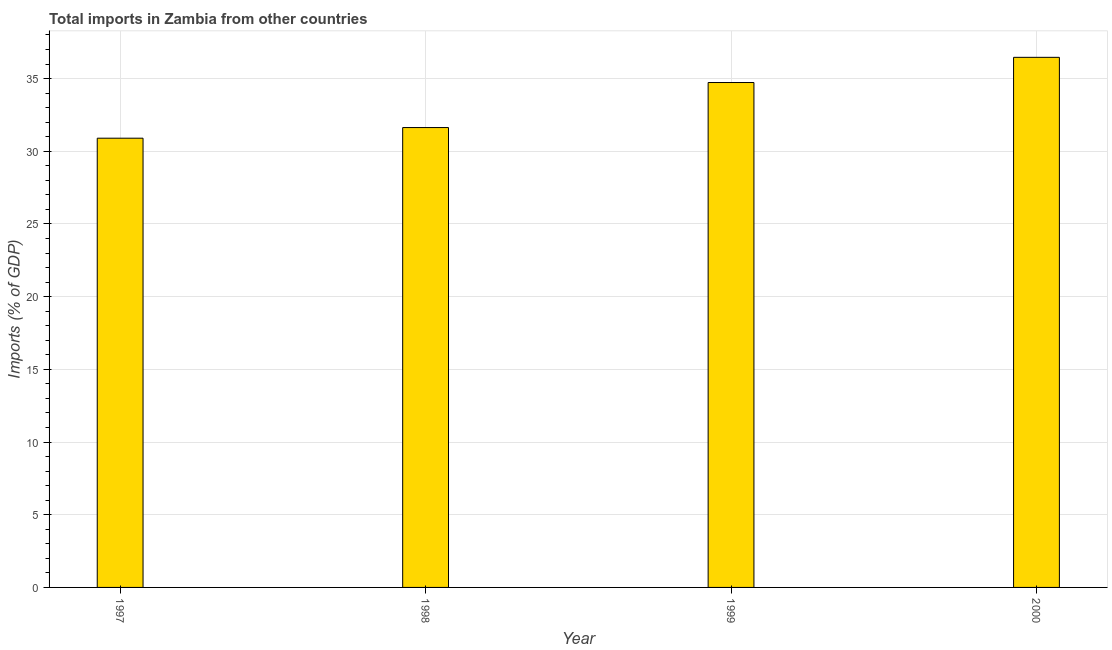What is the title of the graph?
Keep it short and to the point. Total imports in Zambia from other countries. What is the label or title of the Y-axis?
Offer a very short reply. Imports (% of GDP). What is the total imports in 1997?
Keep it short and to the point. 30.9. Across all years, what is the maximum total imports?
Ensure brevity in your answer.  36.46. Across all years, what is the minimum total imports?
Keep it short and to the point. 30.9. In which year was the total imports maximum?
Your answer should be very brief. 2000. In which year was the total imports minimum?
Provide a succinct answer. 1997. What is the sum of the total imports?
Offer a very short reply. 133.73. What is the difference between the total imports in 1997 and 1999?
Your answer should be very brief. -3.83. What is the average total imports per year?
Provide a succinct answer. 33.43. What is the median total imports?
Make the answer very short. 33.18. In how many years, is the total imports greater than 24 %?
Give a very brief answer. 4. Do a majority of the years between 2000 and 1997 (inclusive) have total imports greater than 30 %?
Keep it short and to the point. Yes. What is the ratio of the total imports in 1998 to that in 2000?
Make the answer very short. 0.87. Is the difference between the total imports in 1997 and 2000 greater than the difference between any two years?
Make the answer very short. Yes. What is the difference between the highest and the second highest total imports?
Offer a terse response. 1.73. What is the difference between the highest and the lowest total imports?
Keep it short and to the point. 5.56. In how many years, is the total imports greater than the average total imports taken over all years?
Provide a short and direct response. 2. Are all the bars in the graph horizontal?
Your answer should be compact. No. How many years are there in the graph?
Provide a succinct answer. 4. Are the values on the major ticks of Y-axis written in scientific E-notation?
Your answer should be very brief. No. What is the Imports (% of GDP) of 1997?
Your answer should be very brief. 30.9. What is the Imports (% of GDP) in 1998?
Keep it short and to the point. 31.63. What is the Imports (% of GDP) of 1999?
Your response must be concise. 34.73. What is the Imports (% of GDP) in 2000?
Your answer should be compact. 36.46. What is the difference between the Imports (% of GDP) in 1997 and 1998?
Your answer should be compact. -0.73. What is the difference between the Imports (% of GDP) in 1997 and 1999?
Offer a very short reply. -3.83. What is the difference between the Imports (% of GDP) in 1997 and 2000?
Provide a succinct answer. -5.56. What is the difference between the Imports (% of GDP) in 1998 and 1999?
Ensure brevity in your answer.  -3.1. What is the difference between the Imports (% of GDP) in 1998 and 2000?
Provide a succinct answer. -4.83. What is the difference between the Imports (% of GDP) in 1999 and 2000?
Offer a very short reply. -1.73. What is the ratio of the Imports (% of GDP) in 1997 to that in 1999?
Provide a succinct answer. 0.89. What is the ratio of the Imports (% of GDP) in 1997 to that in 2000?
Ensure brevity in your answer.  0.85. What is the ratio of the Imports (% of GDP) in 1998 to that in 1999?
Ensure brevity in your answer.  0.91. What is the ratio of the Imports (% of GDP) in 1998 to that in 2000?
Make the answer very short. 0.87. 